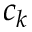<formula> <loc_0><loc_0><loc_500><loc_500>c _ { k }</formula> 